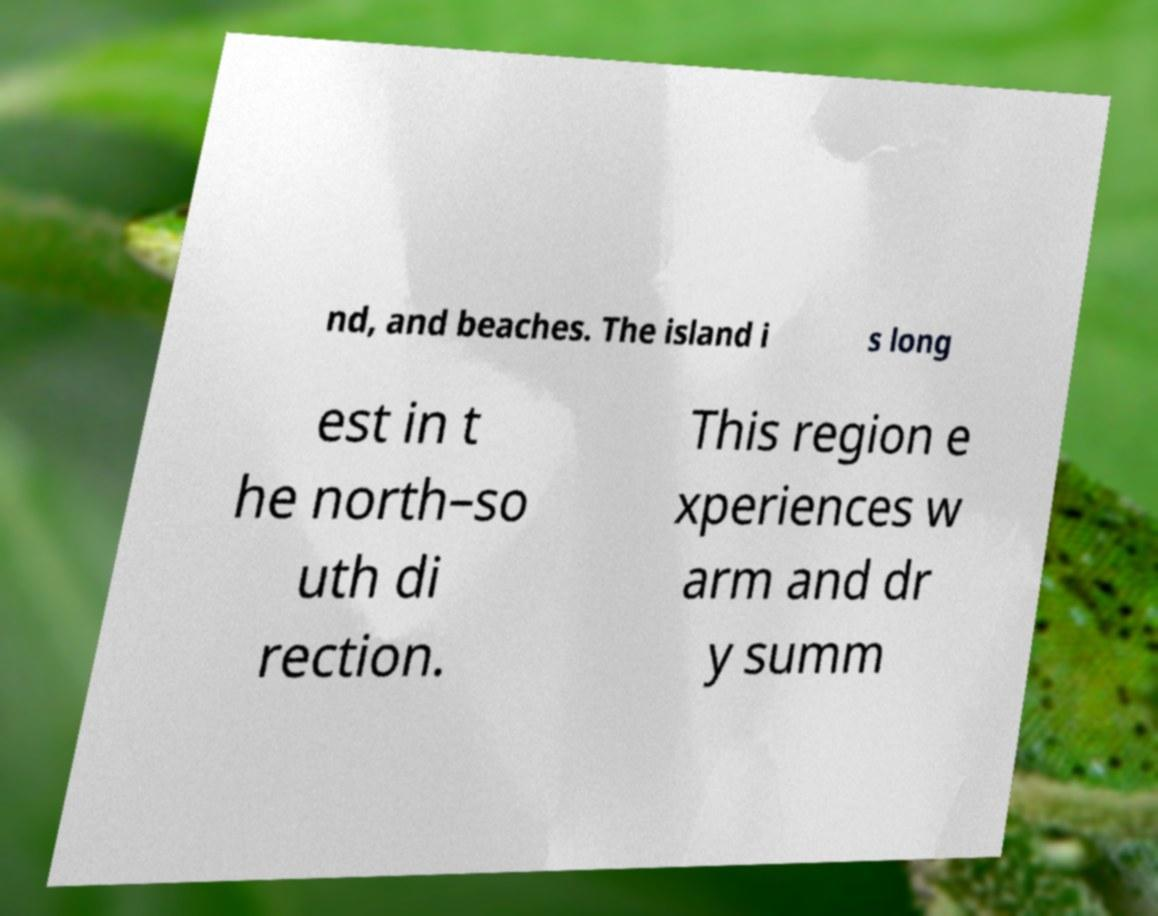Could you assist in decoding the text presented in this image and type it out clearly? nd, and beaches. The island i s long est in t he north–so uth di rection. This region e xperiences w arm and dr y summ 